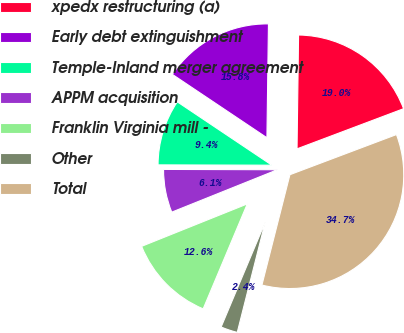Convert chart to OTSL. <chart><loc_0><loc_0><loc_500><loc_500><pie_chart><fcel>xpedx restructuring (a)<fcel>Early debt extinguishment<fcel>Temple-Inland merger agreement<fcel>APPM acquisition<fcel>Franklin Virginia mill -<fcel>Other<fcel>Total<nl><fcel>19.05%<fcel>15.82%<fcel>9.35%<fcel>6.12%<fcel>12.59%<fcel>2.38%<fcel>34.69%<nl></chart> 